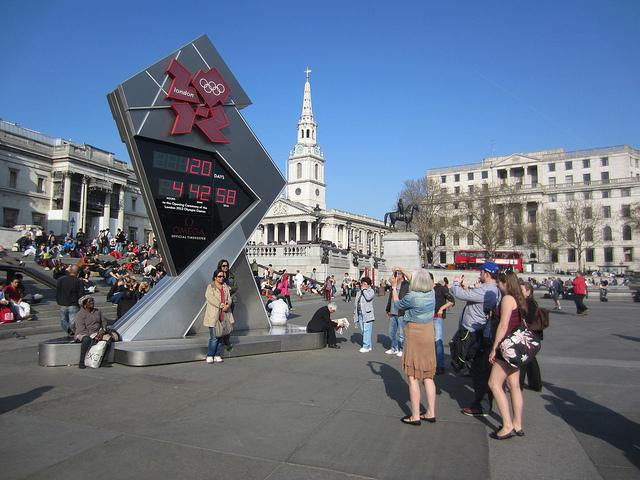What event do the rings signify?

Choices:
A) dolphin show
B) square dance
C) school play
D) olympics olympics 